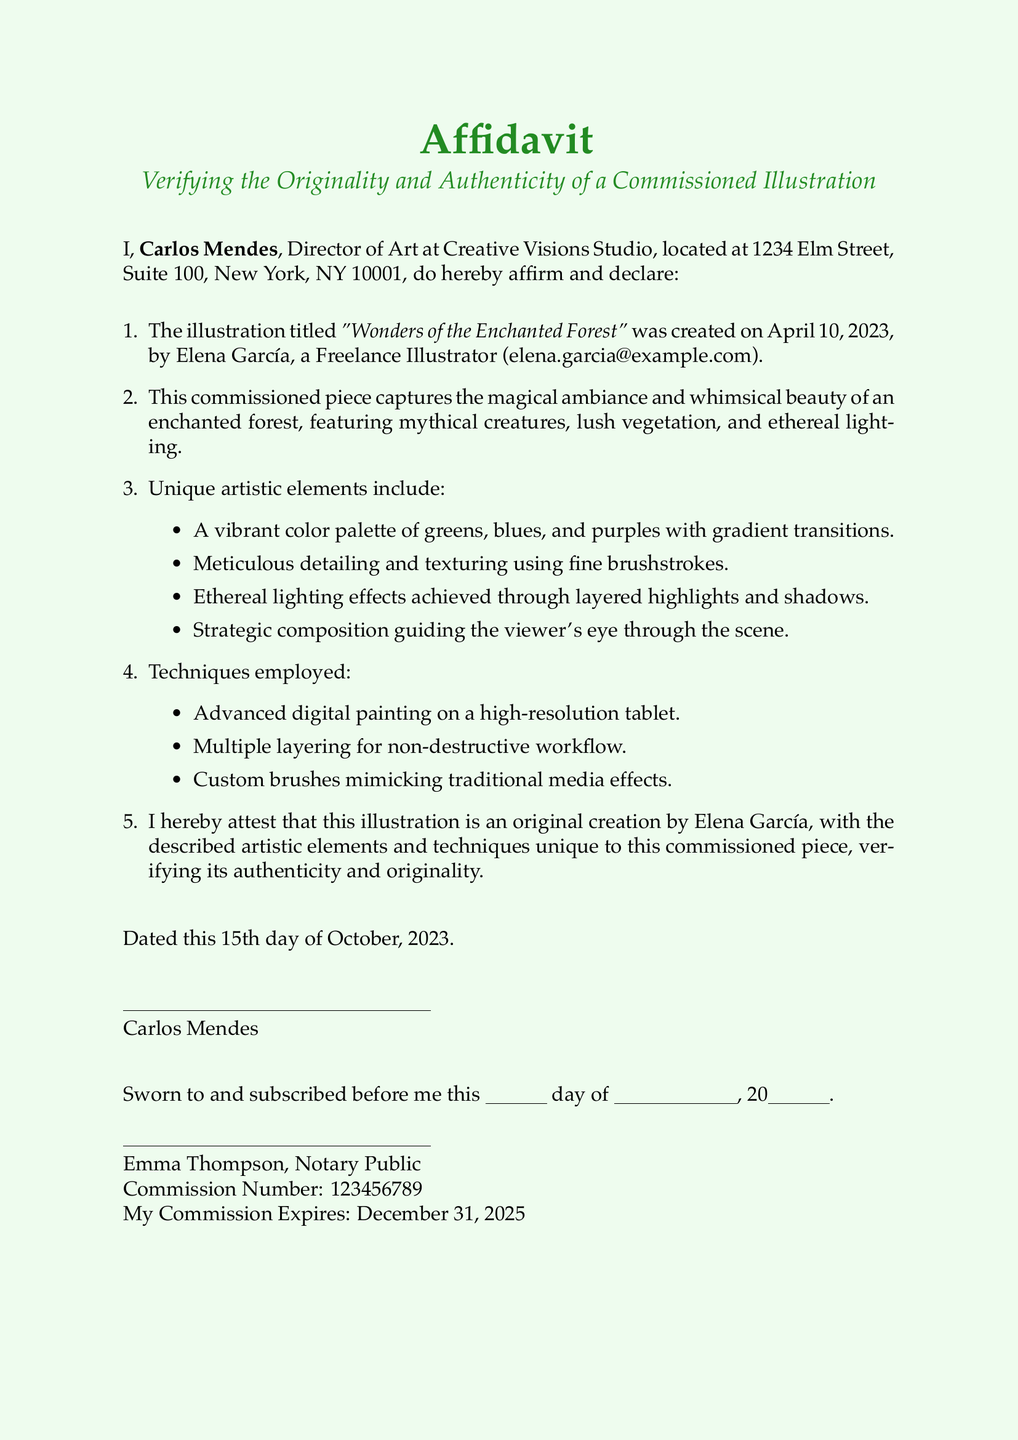What is the title of the illustration? The title is stated in the document as "Wonders of the Enchanted Forest".
Answer: Wonders of the Enchanted Forest Who created the illustration? The creator of the illustration is specifically named as Elena García in the document.
Answer: Elena García When was the illustration created? The creation date is mentioned as April 10, 2023.
Answer: April 10, 2023 What is the vibrant color palette mentioned? The document lists greens, blues, and purples as part of the vibrant color palette.
Answer: Greens, blues, and purples What technique involves using a high-resolution tablet? The technique described is advanced digital painting on a high-resolution tablet.
Answer: Advanced digital painting Who is the Director of Art? The Director of Art is named Carlos Mendes in the affidavit.
Answer: Carlos Mendes What special effects are used in the illustration? The affidavit mentions ethereal lighting effects as one of the artistic elements.
Answer: Ethereal lighting effects What is the commission number of the notary public? The commission number is stated as 123456789 in the document.
Answer: 123456789 What is the expiration date of the notary's commission? The expiration date for the commission is mentioned as December 31, 2025.
Answer: December 31, 2025 